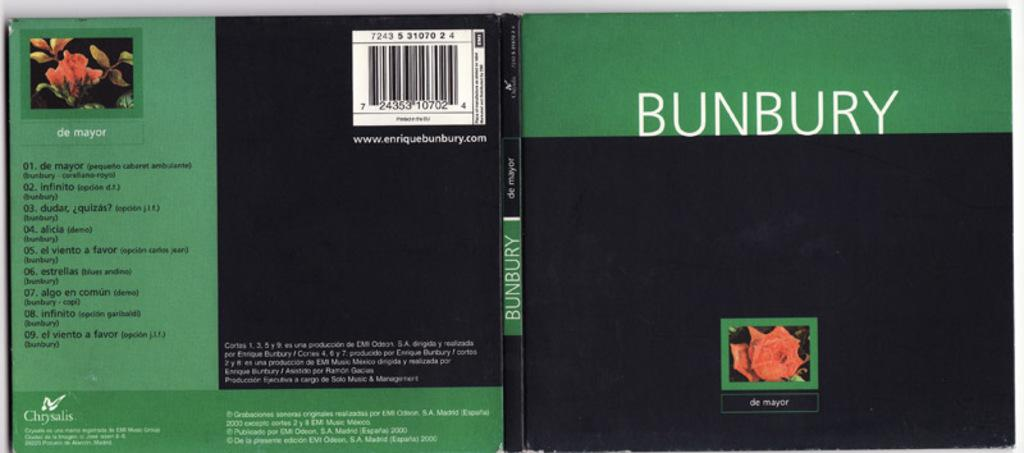Provide a one-sentence caption for the provided image. the word Bunbury is on some CD that is green and black. 